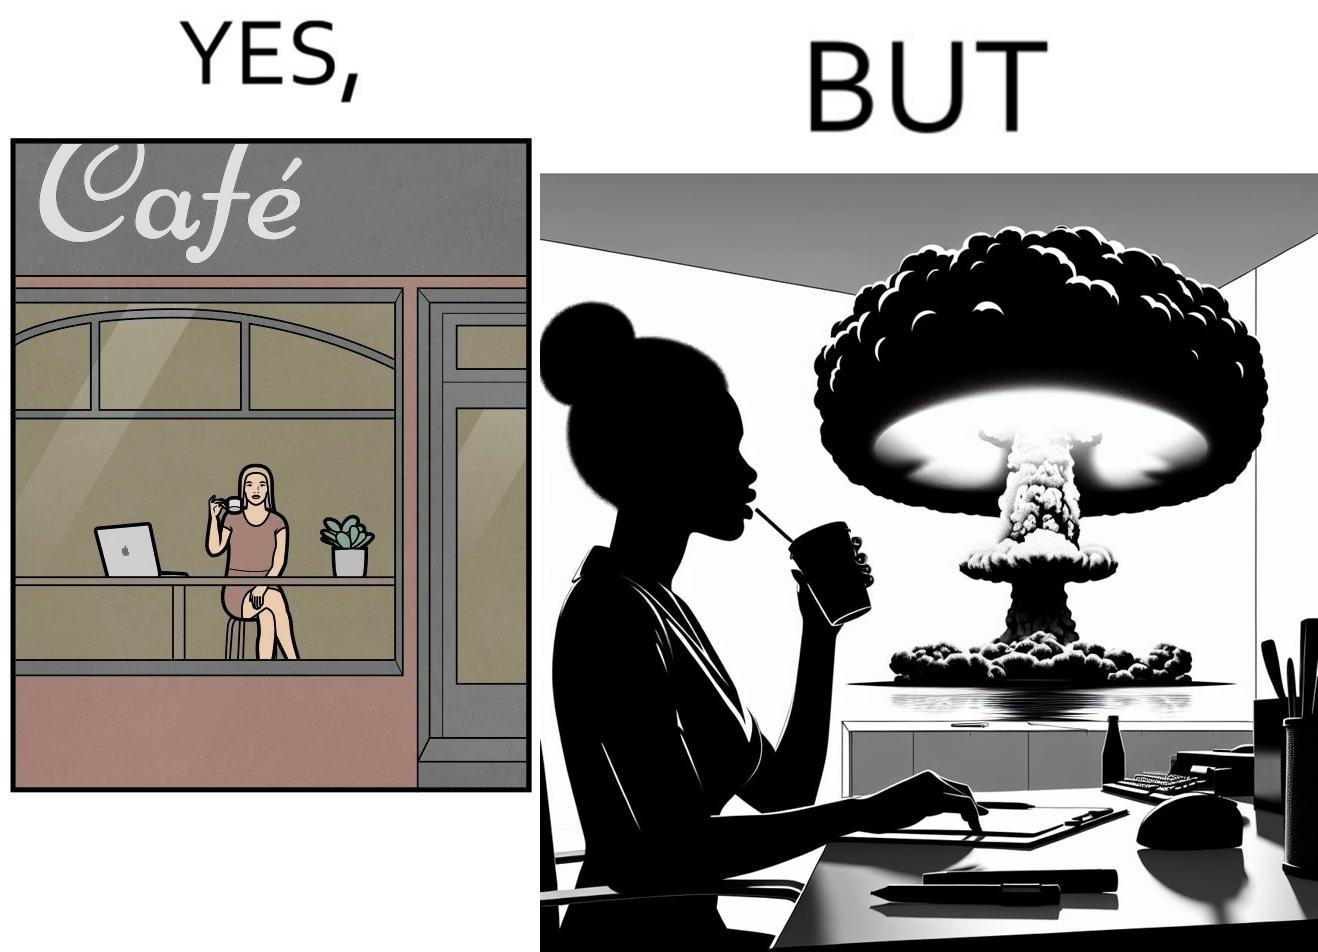What makes this image funny or satirical? The images are funny since it shows a woman simply sipping from a cup at ease in a cafe with her laptop not caring about anything going on outside the cafe even though the situation is very grave,that is, a nuclear blast 